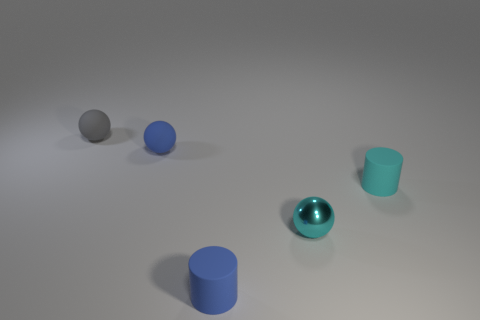Are there any metal things behind the gray thing?
Your answer should be very brief. No. Is there a tiny blue thing that has the same material as the blue cylinder?
Provide a short and direct response. Yes. What size is the other thing that is the same color as the small metallic thing?
Make the answer very short. Small. What number of spheres are either small red things or cyan matte things?
Provide a succinct answer. 0. Are there more tiny matte spheres that are on the right side of the small cyan rubber object than gray things to the right of the shiny sphere?
Provide a short and direct response. No. What number of other things are the same color as the small metal object?
Keep it short and to the point. 1. What is the size of the gray ball that is the same material as the blue cylinder?
Your answer should be compact. Small. What number of objects are tiny rubber objects that are behind the blue rubber cylinder or cyan cylinders?
Keep it short and to the point. 3. Do the small cylinder that is on the right side of the small cyan metal thing and the tiny metal sphere have the same color?
Your answer should be very brief. Yes. What size is the cyan object that is the same shape as the gray rubber thing?
Your answer should be compact. Small. 